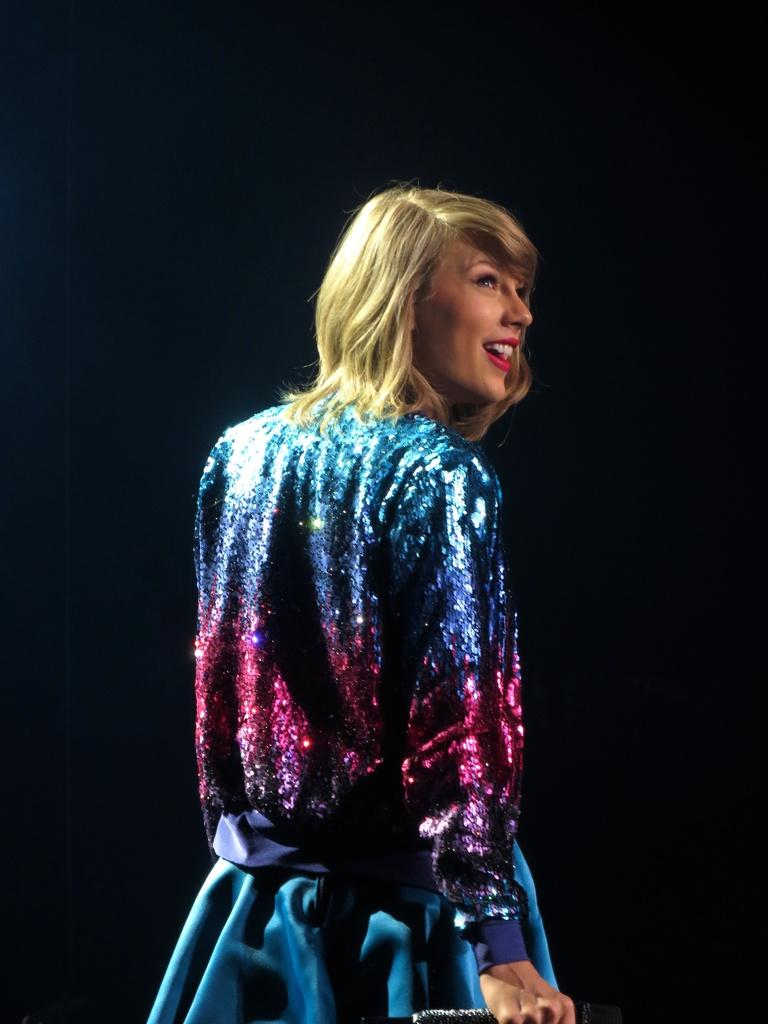Who is present in the image? There is a woman in the image. What is the woman doing in the image? The woman is standing. What is the woman wearing in the image? The woman is wearing a blue, shining dress. What advice does the woman give to the plane in the image? There is no plane present in the image, so the woman cannot give any advice to a plane. 